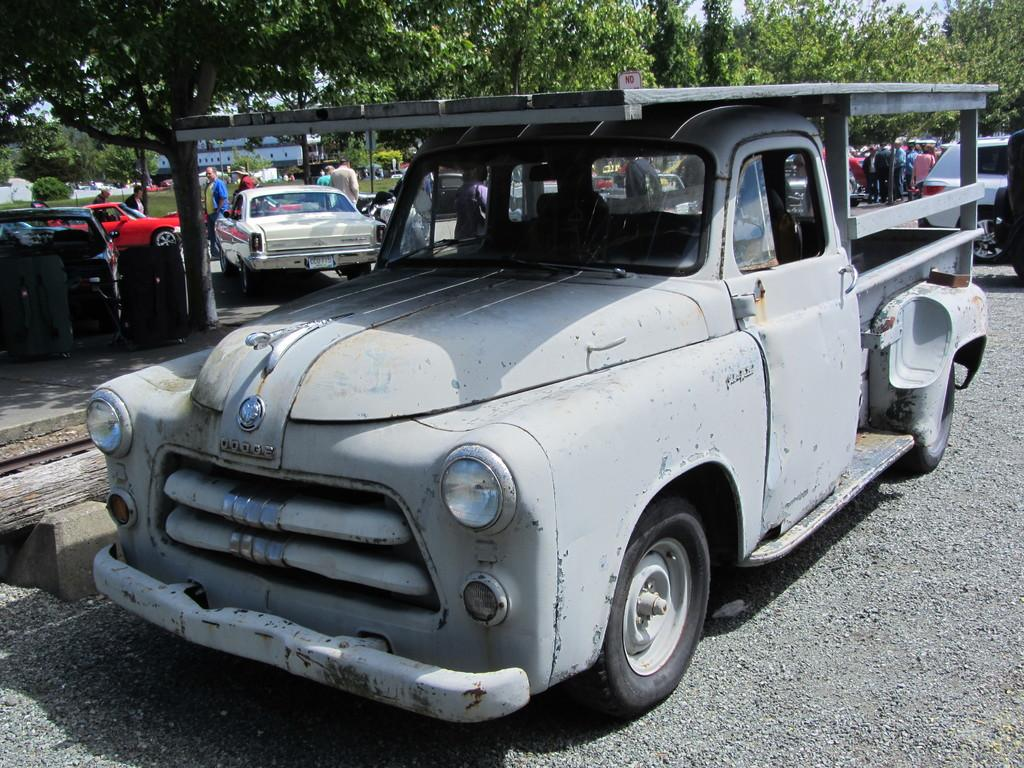What types of objects are present in the image? There are vehicles and people in the image. What is the setting of the image? The image features a road at the bottom and trees and the sky in the background. Can you describe the vehicles in the image? The vehicles in the image are not specified, but they are present. What type of insect can be seen crawling on the shoes in the image? There are no shoes or insects present in the image. How many crows are visible in the image? There are no crows present in the image. 